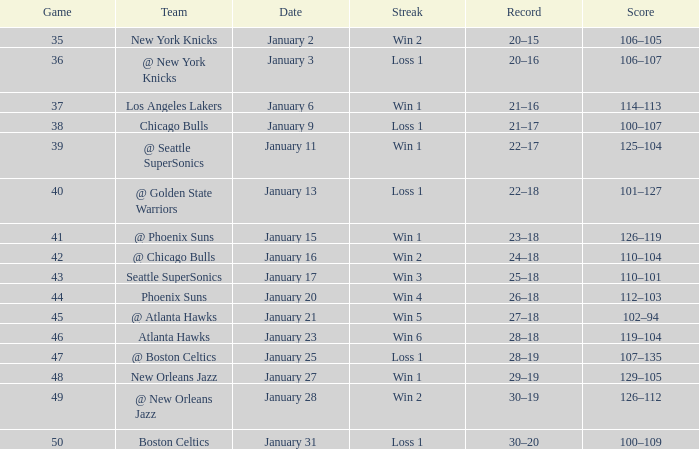What is the Streak in the game with a Record of 20–16? Loss 1. 